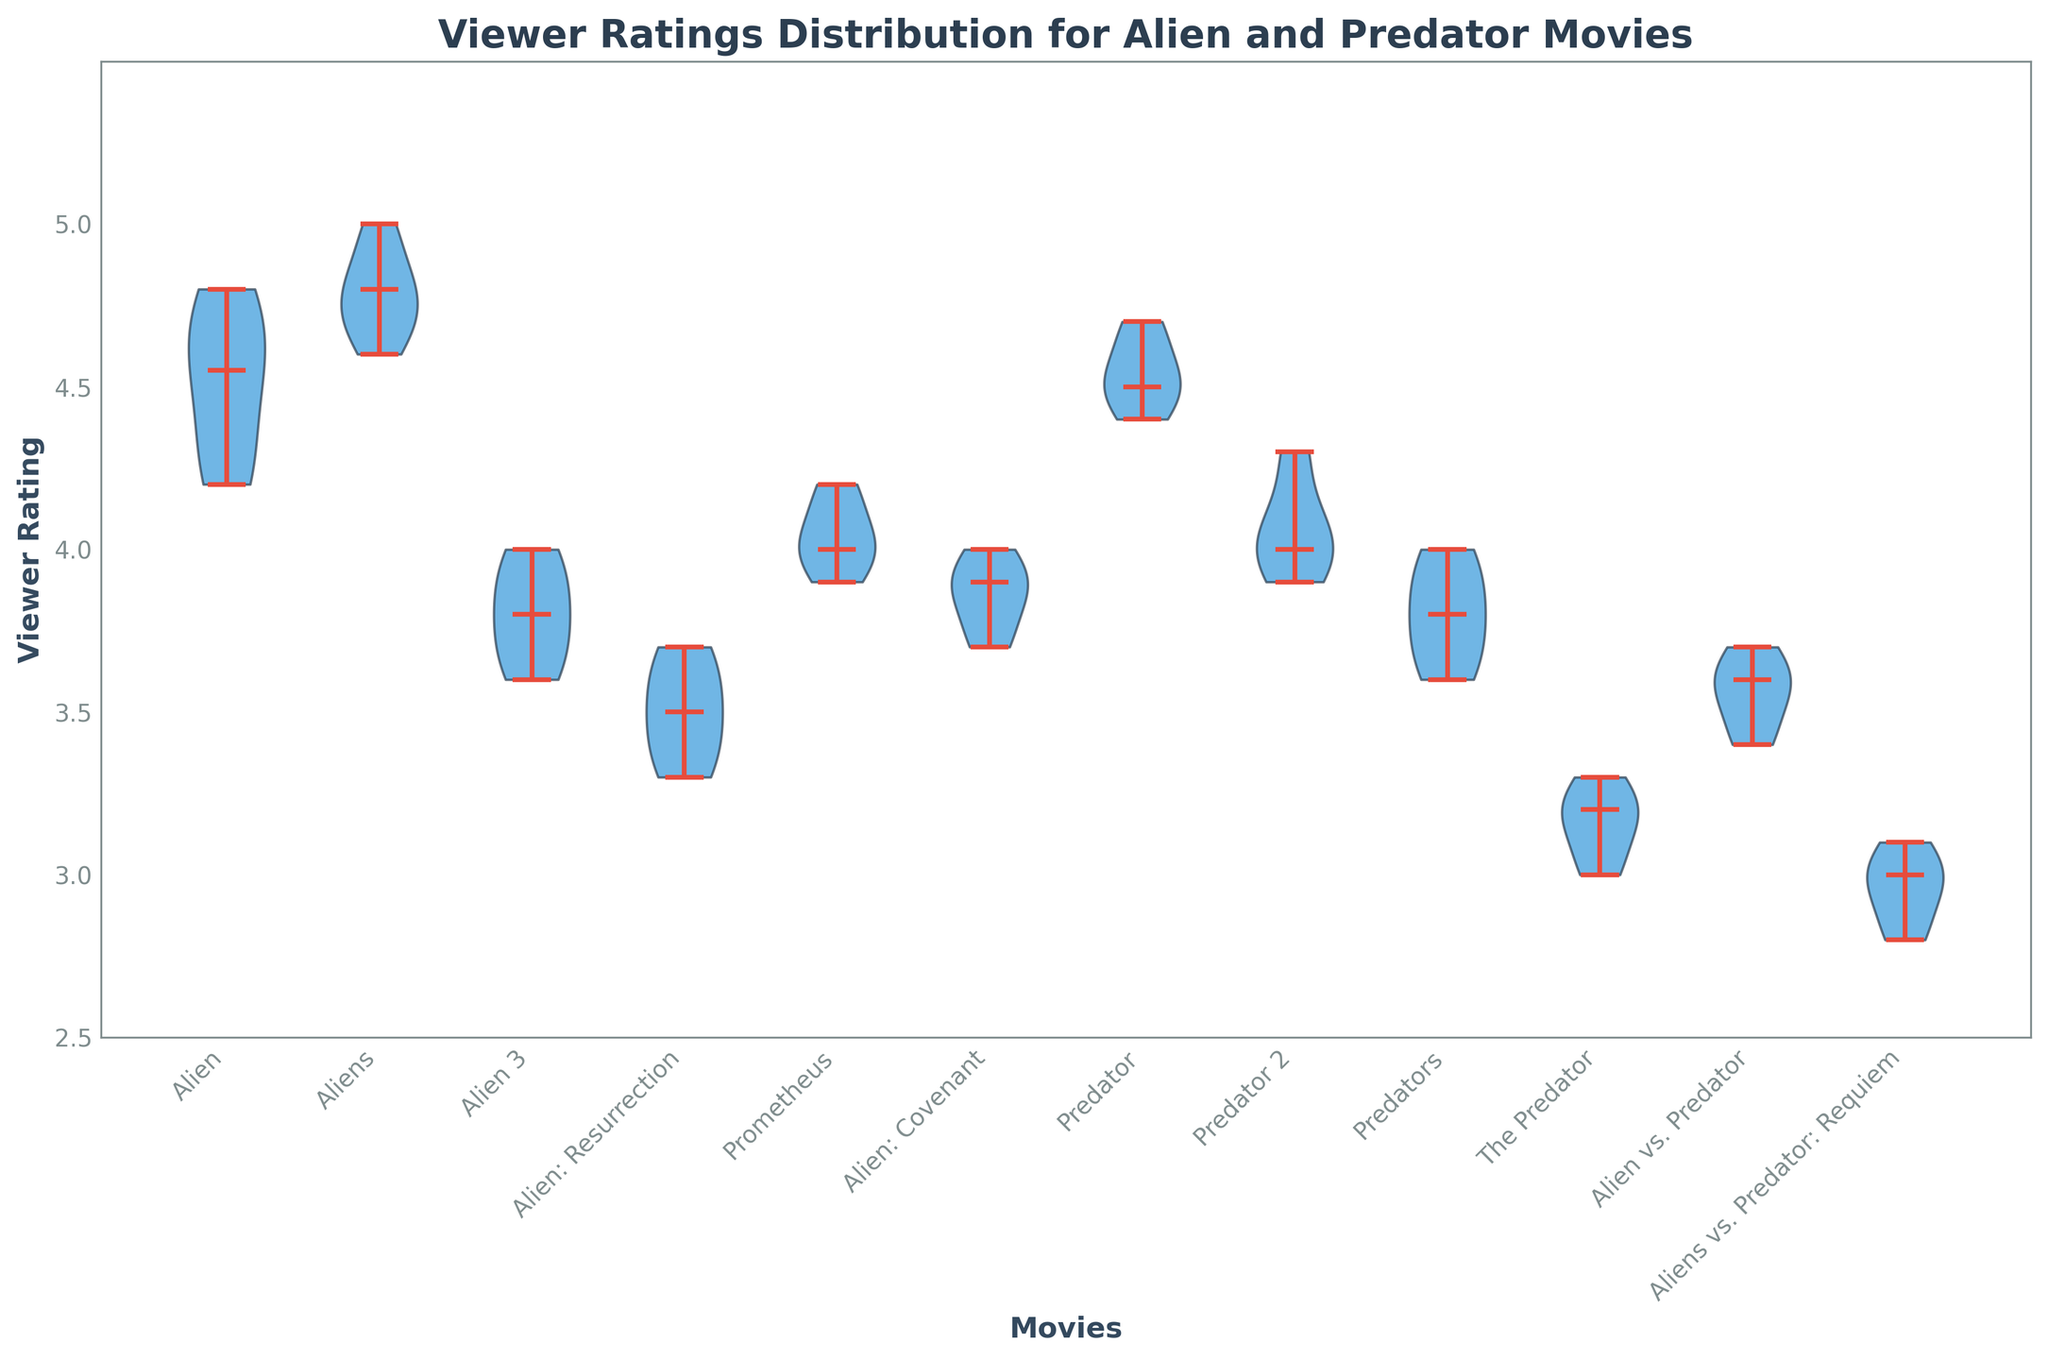What is the title of the chart? The title of the chart is indicated at the top of the plot in large bold text.
Answer: Viewer Ratings Distribution for Alien and Predator Movies What colors are used to represent the violin plot bodies? The bodies of the violins are shaded with a specific color, which is evident by looking at their fill color.
Answer: Blue Which movie has the highest median viewer rating? The median is indicated by a line within each violin plot. The highest median line in comparison to others can be noted along the y-axis.
Answer: Aliens How many movies have their median viewer rating above 4.0? We need to count the number of movies where the median line within the violin plot is above the 4.0 mark on the y-axis.
Answer: Four Compare the median viewer ratings of 'Alien' and 'Predator'. Which one is higher? By comparing the median lines in the violin plots for 'Alien' and 'Predator', we will see which line is higher along the y-axis.
Answer: Alien Which movie has the widest spread of viewer ratings? The spread is represented by the width of the violin plot along the y-axis; the movie with the widest plot has the widest spread.
Answer: Aliens Do any movies have viewer ratings below 3.0? If yes, which ones? We check if any portion of any violin plots extends below the 3.0 mark on the y-axis.
Answer: The Predator, Aliens vs. Predator: Requiem What is the median viewer rating for 'Prometheus'? The median viewer rating is shown by the line inside the violin plot corresponding to 'Prometheus'.
Answer: 4.0 Which movie has the lowest viewer rating spread? The movie with the thinnest violin plot has the smallest spread of viewer ratings.
Answer: Prometheus 